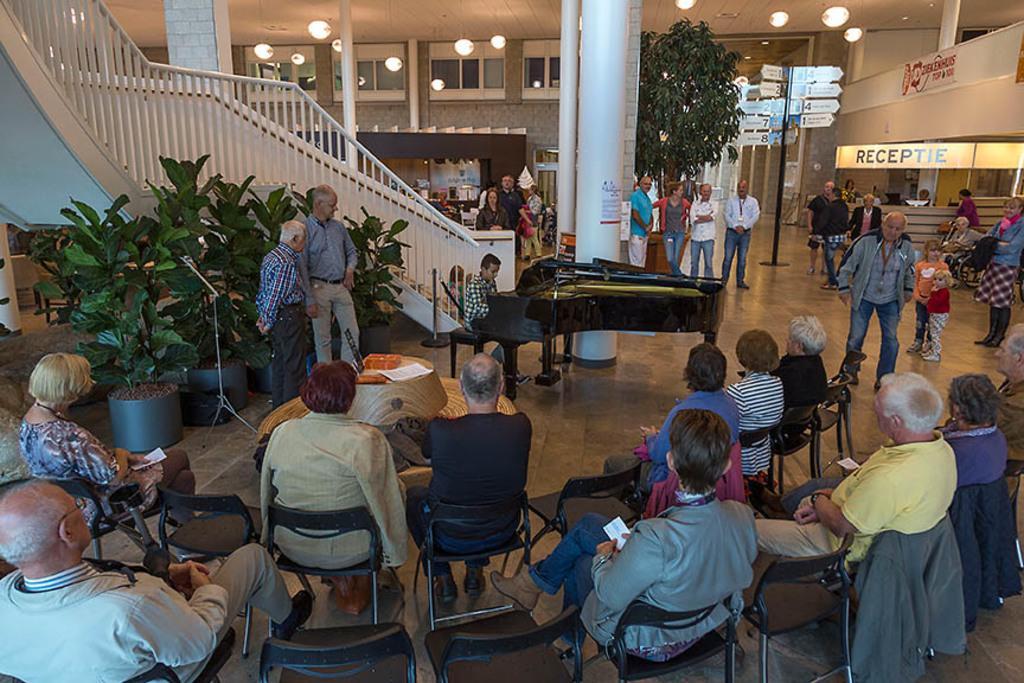Could you give a brief overview of what you see in this image? In this picture we can see some people sitting on chairs, there are some people standing in the background, we can see a piano here, on the left side there are some plants, we can see lights at the top of the picture, there are some boards here, we can see a pillar in the middle. 